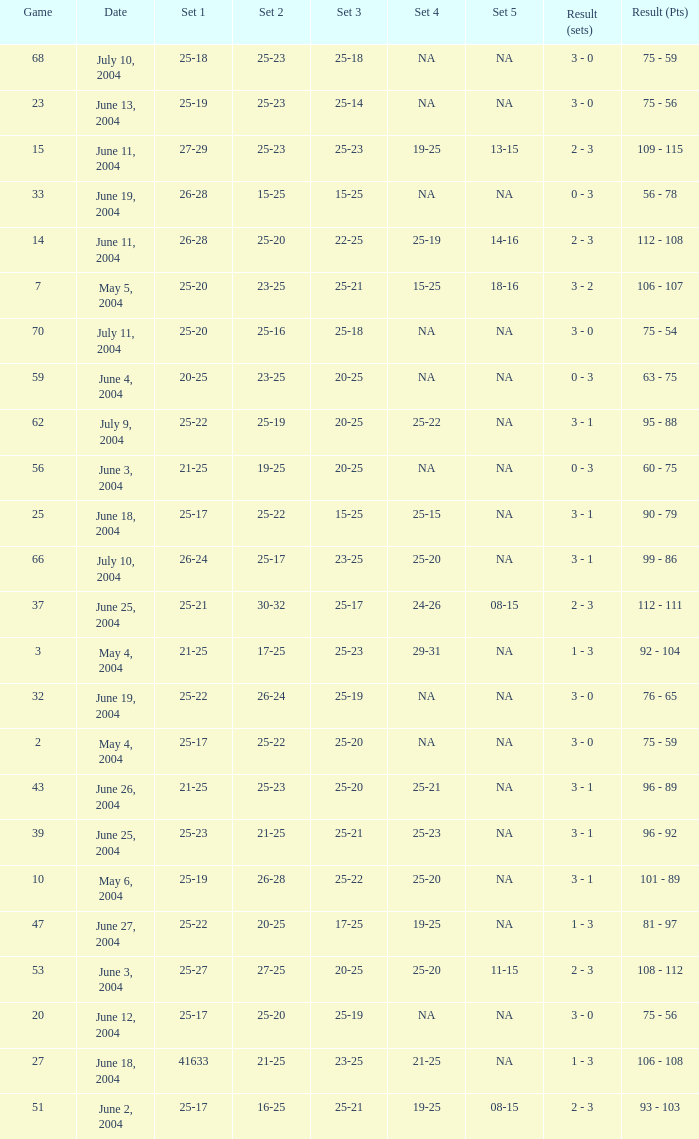What is the set 5 for the game with a set 2 of 21-25 and a set 1 of 41633? NA. 